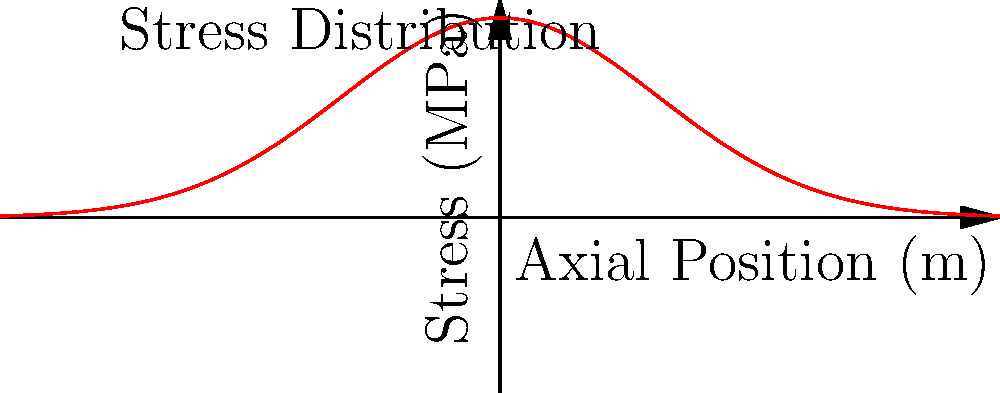Based on the stress distribution shown in the graph for a cylindrical rocket fuel tank under launch conditions, what can be concluded about the location of maximum stress and its implications for tank design? To analyze the stress distribution in the rocket fuel tank:

1. Observe the graph: The curve represents stress distribution along the axial position of the fuel tank.

2. Identify the peak: The maximum stress occurs at the center (x = 0), reaching approximately 4 MPa.

3. Note the symmetry: The stress distribution is symmetrical about the center, decreasing towards both ends.

4. Consider the shape: The distribution follows a Gaussian-like curve, typical for pressurized cylindrical vessels.

5. Interpret the implications:
   a) The center of the tank experiences the highest stress, making it the most critical area for failure.
   b) The ends of the tank have lower stress, allowing for potential weight optimization.
   c) The smooth transition in stress levels suggests a need for uniform material properties along the tank.

6. Design considerations:
   a) Reinforce the central section of the tank to withstand maximum stress.
   b) Potentially use thinner materials at the ends to save weight without compromising structural integrity.
   c) Ensure material selection and manufacturing processes account for the varying stress levels along the tank.

7. Launch condition factors:
   a) The stress distribution accounts for internal pressure and axial loads during launch.
   b) Dynamic loads during ascent may further influence the stress state, requiring additional analysis.
Answer: Maximum stress at center; reinforce middle, optimize ends for weight savings. 